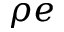<formula> <loc_0><loc_0><loc_500><loc_500>\rho e</formula> 